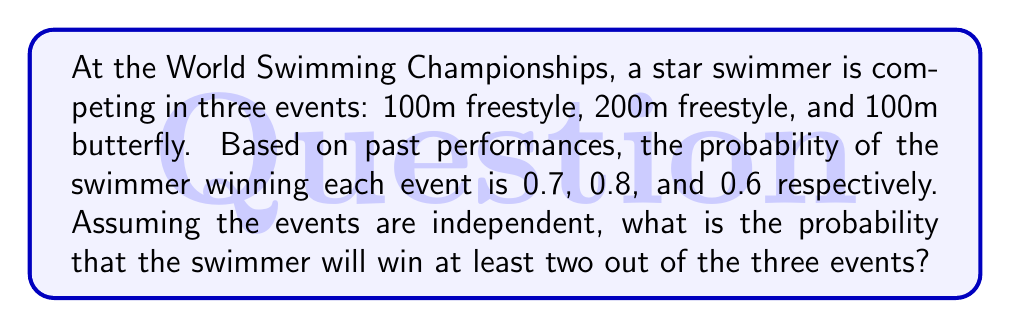Provide a solution to this math problem. Let's approach this step-by-step:

1) First, we need to calculate the probability of winning at least two events. This is equivalent to 1 minus the probability of winning zero or one event.

2) Let's define our events:
   A: Win 100m freestyle (P(A) = 0.7)
   B: Win 200m freestyle (P(B) = 0.8)
   C: Win 100m butterfly (P(C) = 0.6)

3) The probability of winning zero events:
   $$P(\text{zero wins}) = (1-0.7)(1-0.8)(1-0.6) = 0.3 \times 0.2 \times 0.4 = 0.024$$

4) The probability of winning exactly one event:
   $$\begin{align}
   P(\text{one win}) &= 0.7(1-0.8)(1-0.6) + (1-0.7)0.8(1-0.6) + (1-0.7)(1-0.8)0.6 \\
   &= 0.7 \times 0.2 \times 0.4 + 0.3 \times 0.8 \times 0.4 + 0.3 \times 0.2 \times 0.6 \\
   &= 0.056 + 0.096 + 0.036 \\
   &= 0.188
   \end{align}$$

5) Therefore, the probability of winning at least two events is:
   $$\begin{align}
   P(\text{at least two wins}) &= 1 - P(\text{zero wins}) - P(\text{one win}) \\
   &= 1 - 0.024 - 0.188 \\
   &= 0.788
   \end{align}$$
Answer: The probability that the swimmer will win at least two out of the three events is 0.788 or 78.8%. 